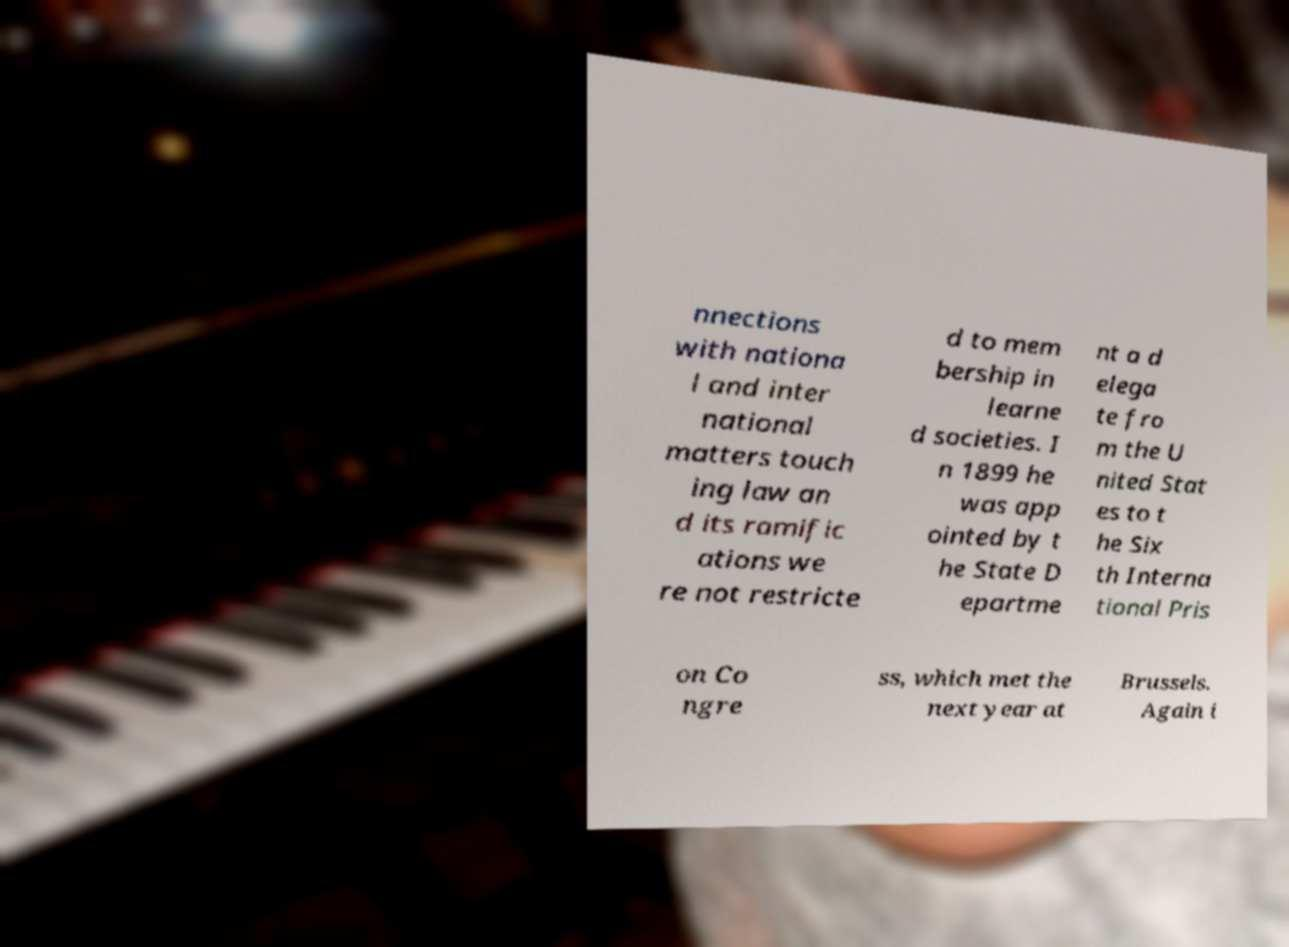Please read and relay the text visible in this image. What does it say? nnections with nationa l and inter national matters touch ing law an d its ramific ations we re not restricte d to mem bership in learne d societies. I n 1899 he was app ointed by t he State D epartme nt a d elega te fro m the U nited Stat es to t he Six th Interna tional Pris on Co ngre ss, which met the next year at Brussels. Again i 